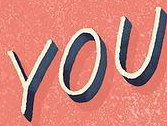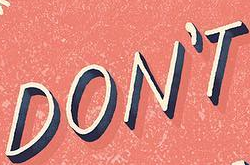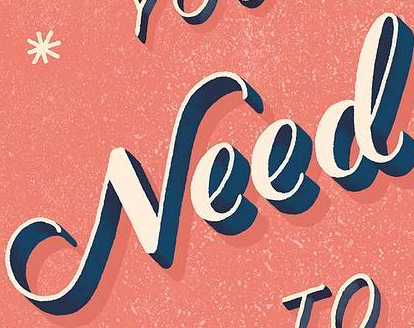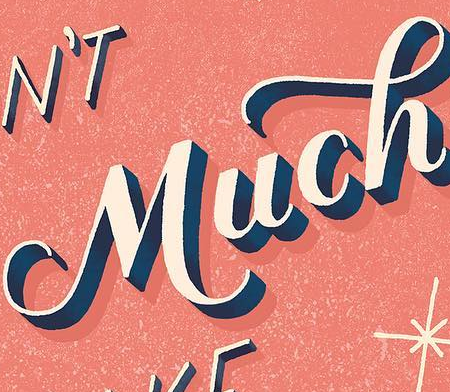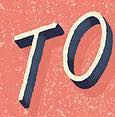Read the text content from these images in order, separated by a semicolon. YOU; DON'T; Need; Much; TO 